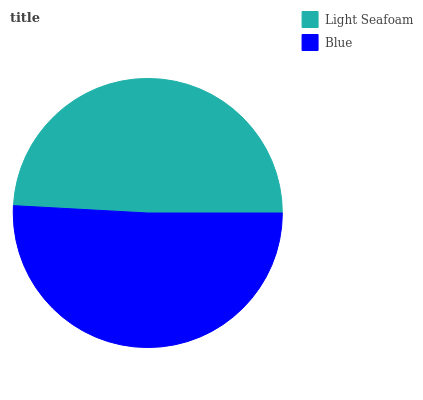Is Light Seafoam the minimum?
Answer yes or no. Yes. Is Blue the maximum?
Answer yes or no. Yes. Is Blue the minimum?
Answer yes or no. No. Is Blue greater than Light Seafoam?
Answer yes or no. Yes. Is Light Seafoam less than Blue?
Answer yes or no. Yes. Is Light Seafoam greater than Blue?
Answer yes or no. No. Is Blue less than Light Seafoam?
Answer yes or no. No. Is Blue the high median?
Answer yes or no. Yes. Is Light Seafoam the low median?
Answer yes or no. Yes. Is Light Seafoam the high median?
Answer yes or no. No. Is Blue the low median?
Answer yes or no. No. 